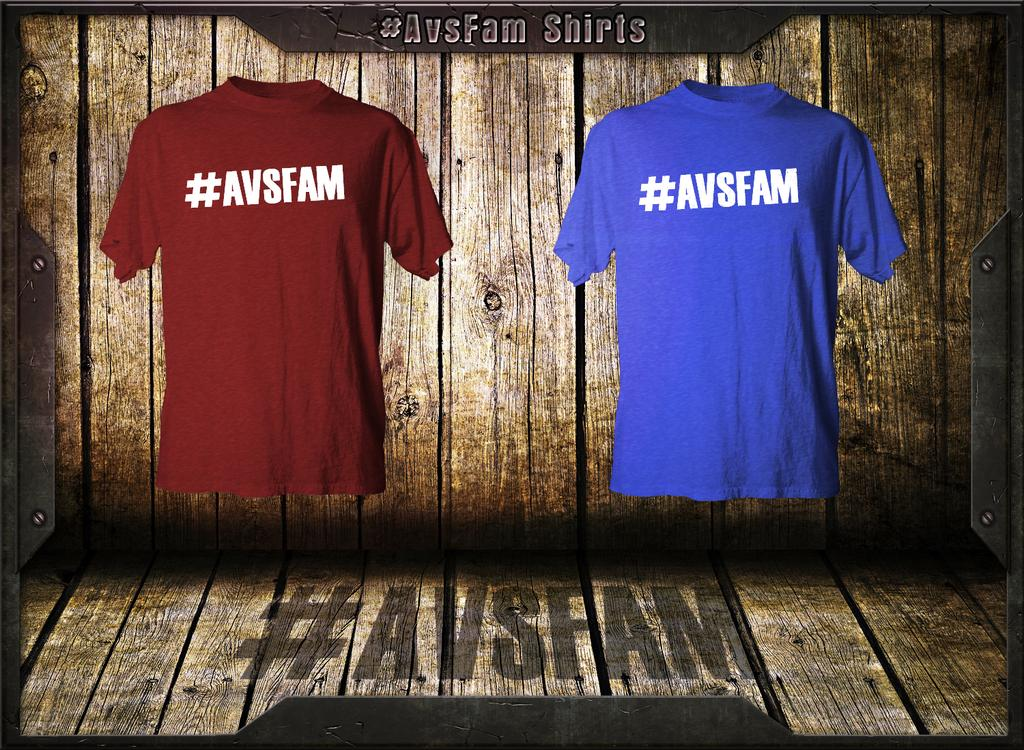Provide a one-sentence caption for the provided image. One red and one blue T-shirt with #AVSFAM on the front. 